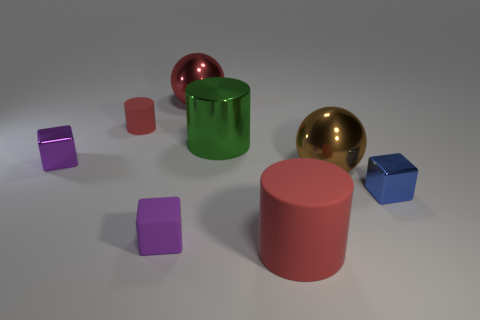Are the blue cube and the cylinder that is behind the metal cylinder made of the same material?
Your response must be concise. No. What number of blue things are the same material as the small blue block?
Offer a very short reply. 0. The rubber object on the right side of the large red ball has what shape?
Offer a terse response. Cylinder. Is the material of the cylinder that is to the left of the green metal cylinder the same as the tiny block right of the big red matte cylinder?
Make the answer very short. No. Is there another green thing that has the same shape as the big matte object?
Offer a terse response. Yes. How many things are metallic spheres that are in front of the green cylinder or large red things?
Provide a short and direct response. 3. Is the number of big rubber things on the right side of the tiny blue cube greater than the number of tiny matte cubes behind the tiny rubber cylinder?
Make the answer very short. No. What number of matte things are tiny objects or yellow things?
Provide a short and direct response. 2. There is another big object that is the same color as the big matte thing; what material is it?
Give a very brief answer. Metal. Is the number of big red rubber cylinders that are right of the big brown metallic thing less than the number of large red cylinders in front of the green cylinder?
Offer a terse response. Yes. 